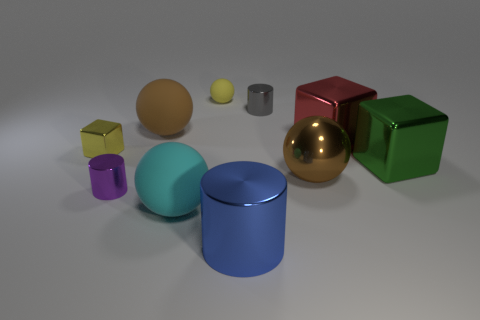What number of other objects are the same color as the small cube?
Your answer should be very brief. 1. What is the size of the cyan thing that is in front of the big brown metallic sphere?
Give a very brief answer. Large. What number of brown shiny blocks are the same size as the red block?
Your answer should be very brief. 0. What material is the small thing that is both in front of the yellow rubber object and right of the purple object?
Provide a short and direct response. Metal. There is a purple cylinder that is the same size as the gray cylinder; what is its material?
Your answer should be compact. Metal. There is a matte ball in front of the large brown object on the left side of the small cylinder behind the big green cube; what size is it?
Your response must be concise. Large. What is the size of the brown sphere that is the same material as the purple cylinder?
Keep it short and to the point. Large. There is a gray cylinder; is it the same size as the cylinder that is to the left of the yellow ball?
Provide a short and direct response. Yes. There is a small gray shiny thing on the right side of the yellow matte object; what is its shape?
Offer a terse response. Cylinder. Is there a yellow metal block that is left of the large matte sphere behind the large ball that is in front of the purple thing?
Your response must be concise. Yes. 